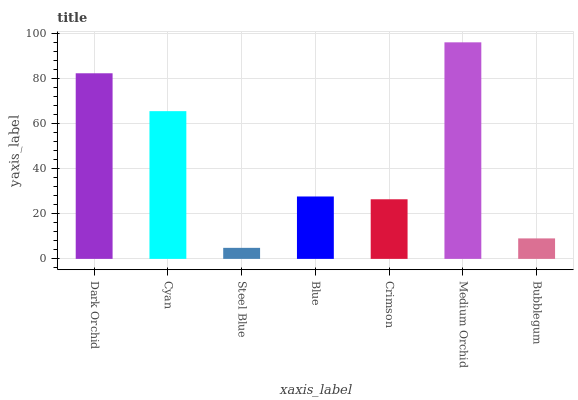Is Steel Blue the minimum?
Answer yes or no. Yes. Is Medium Orchid the maximum?
Answer yes or no. Yes. Is Cyan the minimum?
Answer yes or no. No. Is Cyan the maximum?
Answer yes or no. No. Is Dark Orchid greater than Cyan?
Answer yes or no. Yes. Is Cyan less than Dark Orchid?
Answer yes or no. Yes. Is Cyan greater than Dark Orchid?
Answer yes or no. No. Is Dark Orchid less than Cyan?
Answer yes or no. No. Is Blue the high median?
Answer yes or no. Yes. Is Blue the low median?
Answer yes or no. Yes. Is Crimson the high median?
Answer yes or no. No. Is Medium Orchid the low median?
Answer yes or no. No. 